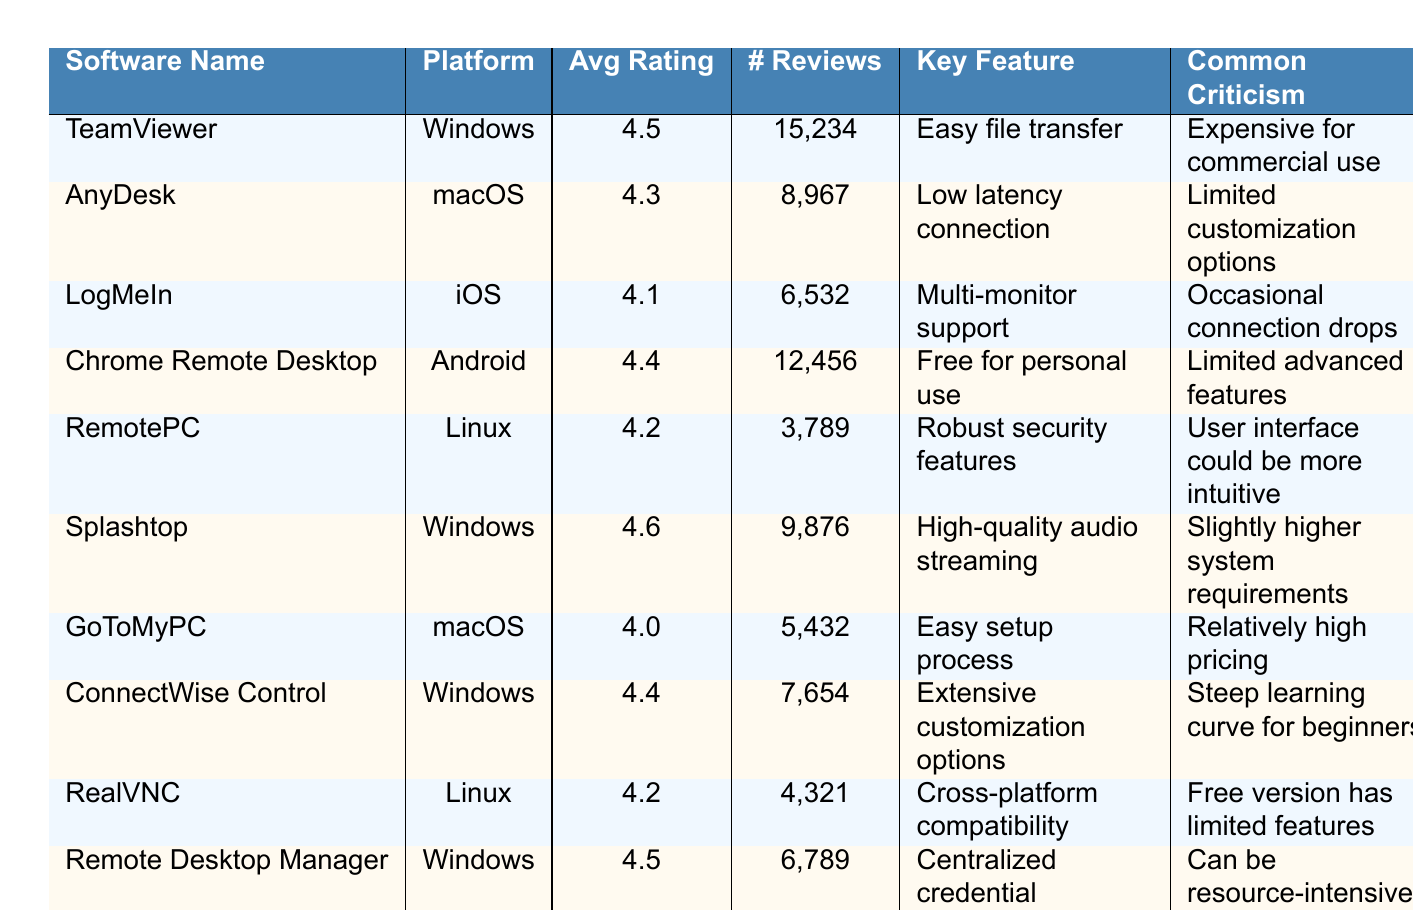What is the average user rating of TeamViewer? The table states that TeamViewer has an average user rating of 4.5.
Answer: 4.5 Which software has the highest average user rating? Splashtop has the highest average user rating at 4.6, as indicated in the table.
Answer: Splashtop How many reviews does AnyDesk have? The table lists that AnyDesk has received 8,967 reviews.
Answer: 8967 What is the most common criticism for Chrome Remote Desktop? The table shows that the most common criticism for Chrome Remote Desktop is that it has limited advanced features.
Answer: Limited advanced features Is the average user rating of GoToMyPC higher than 4.0? Yes, the average user rating of GoToMyPC is 4.0, so it is not higher than 4.0, but it is exactly 4.0.
Answer: No How many total reviews do RemotePC and RealVNC have combined? RemotePC has 3,789 reviews and RealVNC has 4,321 reviews. Adding these together gives 3,789 + 4,321 = 8,110.
Answer: 8110 Which platform has the software with the lowest average rating? LogMeIn has the lowest average rating at 4.1, and it is on the iOS platform, as shown in the table.
Answer: iOS What key feature is highlighted for Remote Desktop Manager? The table states that the key feature for Remote Desktop Manager is centralized credential management.
Answer: Centralized credential management Which software is criticized for being expensive for commercial use? The table indicates that TeamViewer is criticized for being expensive for commercial use.
Answer: TeamViewer If we rank the software based on their average user rating, what would be the median rating? The average user ratings of the software in order are: 4.0 (GoToMyPC), 4.1 (LogMeIn), 4.2 (RemotePC, RealVNC), 4.3 (AnyDesk), 4.4 (Chrome Remote Desktop, ConnectWise Control), 4.5 (TeamViewer, Remote Desktop Manager), 4.6 (Splashtop). The median value with 10 items is the average of the 5th and 6th, which are 4.4 and 4.5, so (4.4 + 4.5) / 2 = 4.45.
Answer: 4.45 Which software provides robust security features according to user reviews? RemotePC is noted for its robust security features in the table.
Answer: RemotePC Are there any software options that have an average rating of 4.4? Yes, both Chrome Remote Desktop and ConnectWise Control have an average rating of 4.4.
Answer: Yes What is a common criticism of the software with low latency connection? AnyDesk, which has a low latency connection, is commonly criticized for its limited customization options.
Answer: Limited customization options 